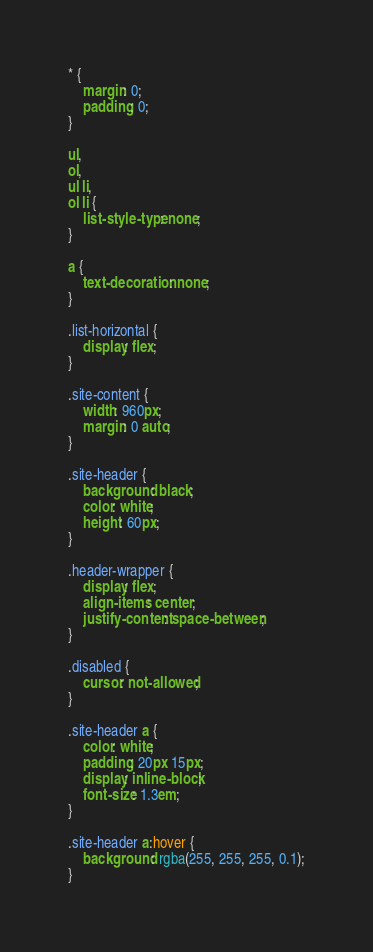Convert code to text. <code><loc_0><loc_0><loc_500><loc_500><_CSS_>* {
    margin: 0;
    padding: 0;
}

ul,
ol,
ul li,
ol li {
    list-style-type: none;
}

a {
    text-decoration: none;
}

.list-horizontal {
    display: flex;
}

.site-content {
    width: 960px;
    margin: 0 auto;
}

.site-header {
    background: black;
    color: white;
    height: 60px;
}

.header-wrapper {
    display: flex;
    align-items: center;
    justify-content: space-between;
}

.disabled {
    cursor: not-allowed;
}

.site-header a {
    color: white;
    padding: 20px 15px;
    display: inline-block;
    font-size: 1.3em;
}

.site-header a:hover {
    background: rgba(255, 255, 255, 0.1);
}

</code> 